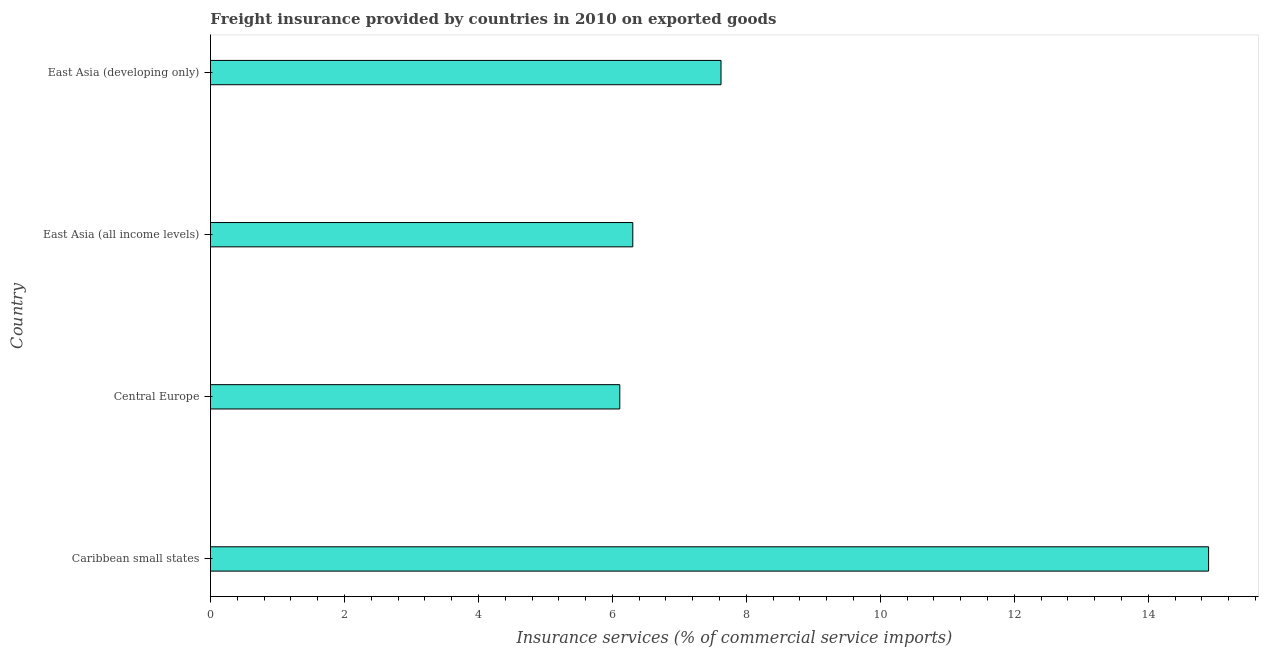Does the graph contain grids?
Offer a very short reply. No. What is the title of the graph?
Give a very brief answer. Freight insurance provided by countries in 2010 on exported goods . What is the label or title of the X-axis?
Your answer should be compact. Insurance services (% of commercial service imports). What is the freight insurance in Caribbean small states?
Your response must be concise. 14.9. Across all countries, what is the maximum freight insurance?
Provide a succinct answer. 14.9. Across all countries, what is the minimum freight insurance?
Provide a succinct answer. 6.11. In which country was the freight insurance maximum?
Provide a succinct answer. Caribbean small states. In which country was the freight insurance minimum?
Your response must be concise. Central Europe. What is the sum of the freight insurance?
Offer a very short reply. 34.94. What is the difference between the freight insurance in Caribbean small states and Central Europe?
Offer a terse response. 8.79. What is the average freight insurance per country?
Make the answer very short. 8.73. What is the median freight insurance?
Provide a succinct answer. 6.96. In how many countries, is the freight insurance greater than 14.4 %?
Provide a succinct answer. 1. What is the ratio of the freight insurance in East Asia (all income levels) to that in East Asia (developing only)?
Keep it short and to the point. 0.83. Is the freight insurance in Caribbean small states less than that in East Asia (all income levels)?
Your answer should be very brief. No. Is the difference between the freight insurance in Caribbean small states and East Asia (developing only) greater than the difference between any two countries?
Your answer should be very brief. No. What is the difference between the highest and the second highest freight insurance?
Your answer should be compact. 7.28. What is the difference between the highest and the lowest freight insurance?
Offer a very short reply. 8.79. In how many countries, is the freight insurance greater than the average freight insurance taken over all countries?
Your response must be concise. 1. How many bars are there?
Give a very brief answer. 4. Are all the bars in the graph horizontal?
Offer a very short reply. Yes. How many countries are there in the graph?
Make the answer very short. 4. What is the Insurance services (% of commercial service imports) of Caribbean small states?
Offer a very short reply. 14.9. What is the Insurance services (% of commercial service imports) of Central Europe?
Offer a very short reply. 6.11. What is the Insurance services (% of commercial service imports) of East Asia (all income levels)?
Your answer should be compact. 6.3. What is the Insurance services (% of commercial service imports) in East Asia (developing only)?
Provide a succinct answer. 7.62. What is the difference between the Insurance services (% of commercial service imports) in Caribbean small states and Central Europe?
Offer a terse response. 8.79. What is the difference between the Insurance services (% of commercial service imports) in Caribbean small states and East Asia (all income levels)?
Your answer should be very brief. 8.6. What is the difference between the Insurance services (% of commercial service imports) in Caribbean small states and East Asia (developing only)?
Give a very brief answer. 7.28. What is the difference between the Insurance services (% of commercial service imports) in Central Europe and East Asia (all income levels)?
Offer a very short reply. -0.19. What is the difference between the Insurance services (% of commercial service imports) in Central Europe and East Asia (developing only)?
Make the answer very short. -1.51. What is the difference between the Insurance services (% of commercial service imports) in East Asia (all income levels) and East Asia (developing only)?
Give a very brief answer. -1.32. What is the ratio of the Insurance services (% of commercial service imports) in Caribbean small states to that in Central Europe?
Offer a terse response. 2.44. What is the ratio of the Insurance services (% of commercial service imports) in Caribbean small states to that in East Asia (all income levels)?
Offer a terse response. 2.36. What is the ratio of the Insurance services (% of commercial service imports) in Caribbean small states to that in East Asia (developing only)?
Your answer should be compact. 1.96. What is the ratio of the Insurance services (% of commercial service imports) in Central Europe to that in East Asia (developing only)?
Offer a very short reply. 0.8. What is the ratio of the Insurance services (% of commercial service imports) in East Asia (all income levels) to that in East Asia (developing only)?
Provide a short and direct response. 0.83. 